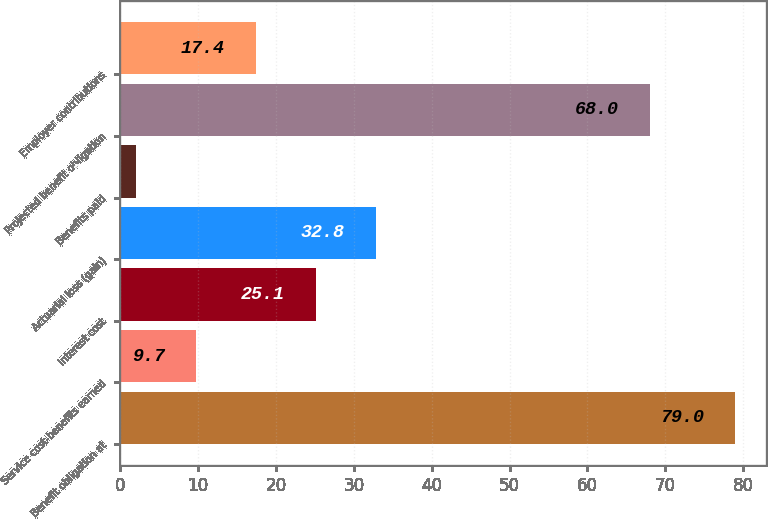<chart> <loc_0><loc_0><loc_500><loc_500><bar_chart><fcel>Benefit obligation at<fcel>Service cost-benefits earned<fcel>Interest cost<fcel>Actuarial loss (gain)<fcel>Benefits paid<fcel>Projected benefit obligation<fcel>Employer contributions<nl><fcel>79<fcel>9.7<fcel>25.1<fcel>32.8<fcel>2<fcel>68<fcel>17.4<nl></chart> 